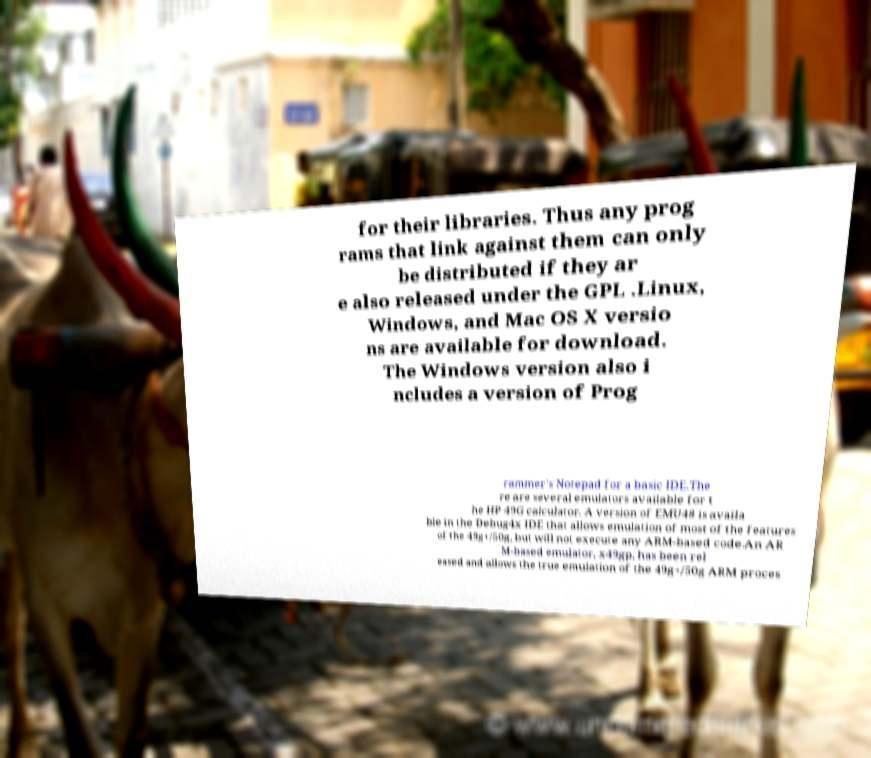What messages or text are displayed in this image? I need them in a readable, typed format. for their libraries. Thus any prog rams that link against them can only be distributed if they ar e also released under the GPL .Linux, Windows, and Mac OS X versio ns are available for download. The Windows version also i ncludes a version of Prog rammer's Notepad for a basic IDE.The re are several emulators available for t he HP 49G calculator. A version of EMU48 is availa ble in the Debug4x IDE that allows emulation of most of the features of the 49g+/50g, but will not execute any ARM-based code.An AR M-based emulator, x49gp, has been rel eased and allows the true emulation of the 49g+/50g ARM proces 